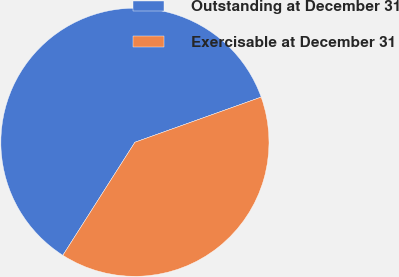Convert chart. <chart><loc_0><loc_0><loc_500><loc_500><pie_chart><fcel>Outstanding at December 31<fcel>Exercisable at December 31<nl><fcel>60.5%<fcel>39.5%<nl></chart> 